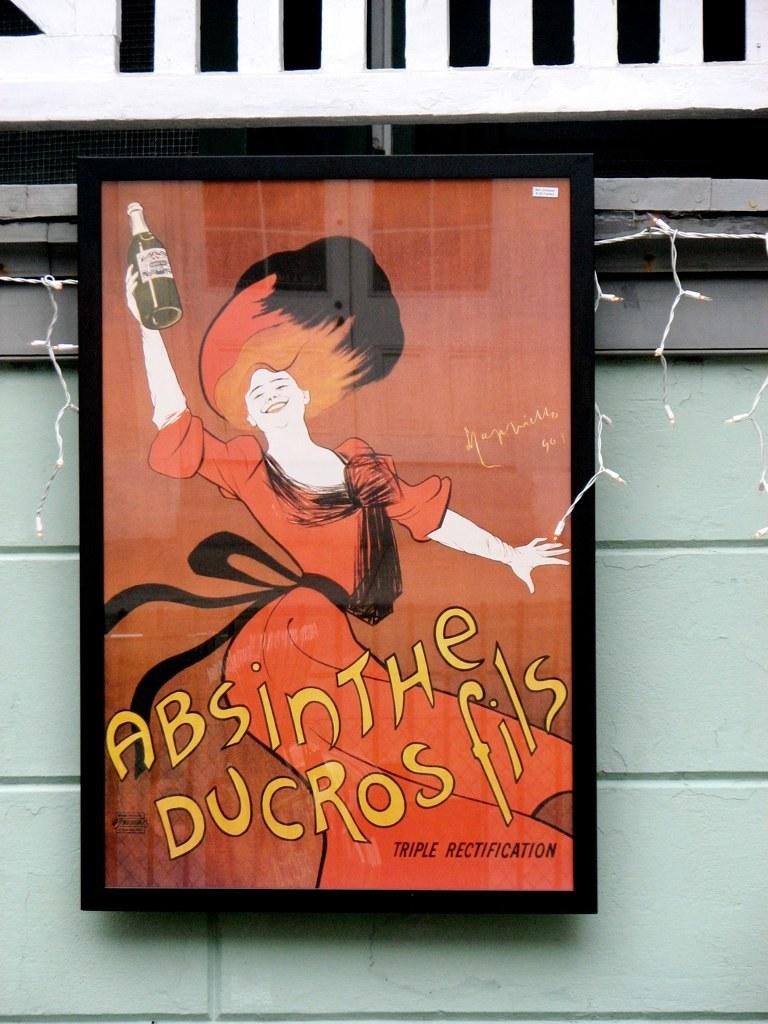What is the main object in the center of the image? There is a board in the center of the image. What can be seen on the board? There is text on the board. What is visible in the background of the image? There is a wall, lights, and a railing in the background of the image. Can you see a pig using its tongue to catch a zephyr in the image? There is no pig or zephyr present in the image. 